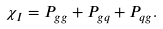<formula> <loc_0><loc_0><loc_500><loc_500>\chi _ { I } = P _ { g g } + P _ { g q } + P _ { q g } .</formula> 